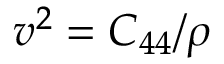Convert formula to latex. <formula><loc_0><loc_0><loc_500><loc_500>v ^ { 2 } = C _ { 4 4 } / \rho</formula> 